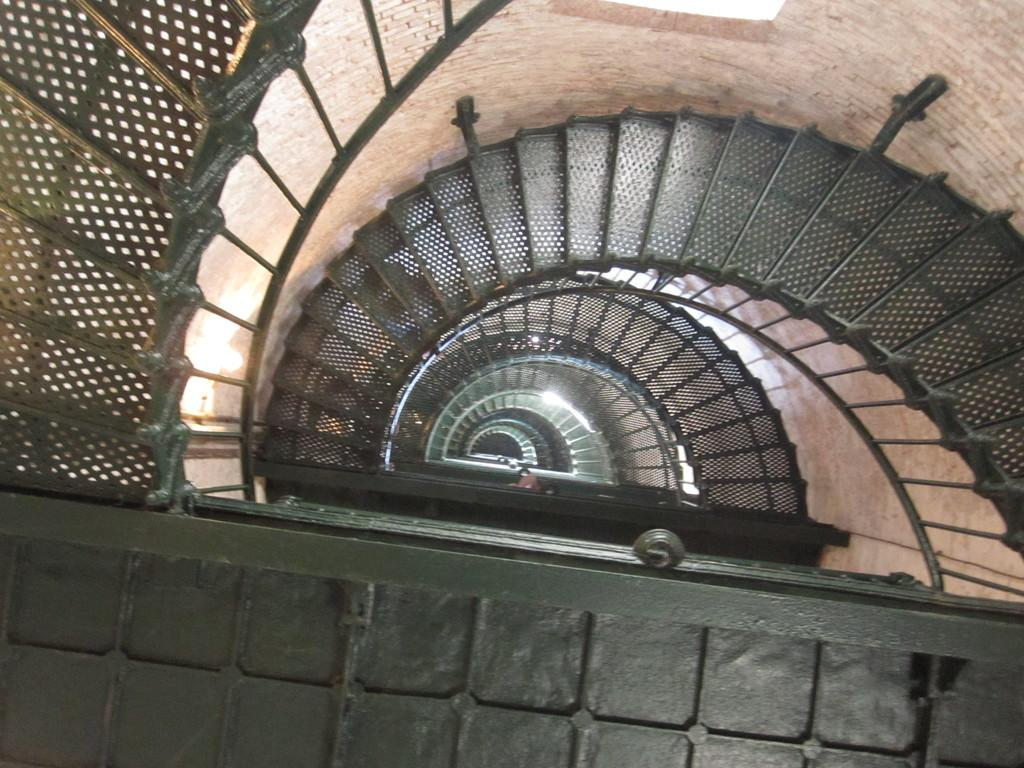What type of structure is present in the image? There are stairs in the image. What feature do the stairs have? The stairs have a railing. How are the stairs arranged in the image? The stairs are in a semi-circular shape. What else can be seen in the image besides the stairs? There are lights visible in the image. What type of car is parked near the stairs in the image? There is no car present in the image; it only features stairs and lights. Can you describe the picture hanging on the wall near the stairs? There is no picture hanging on the wall near the stairs in the image. 